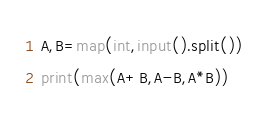Convert code to text. <code><loc_0><loc_0><loc_500><loc_500><_Python_>A,B=map(int,input().split())
print(max(A+B,A-B,A*B))</code> 